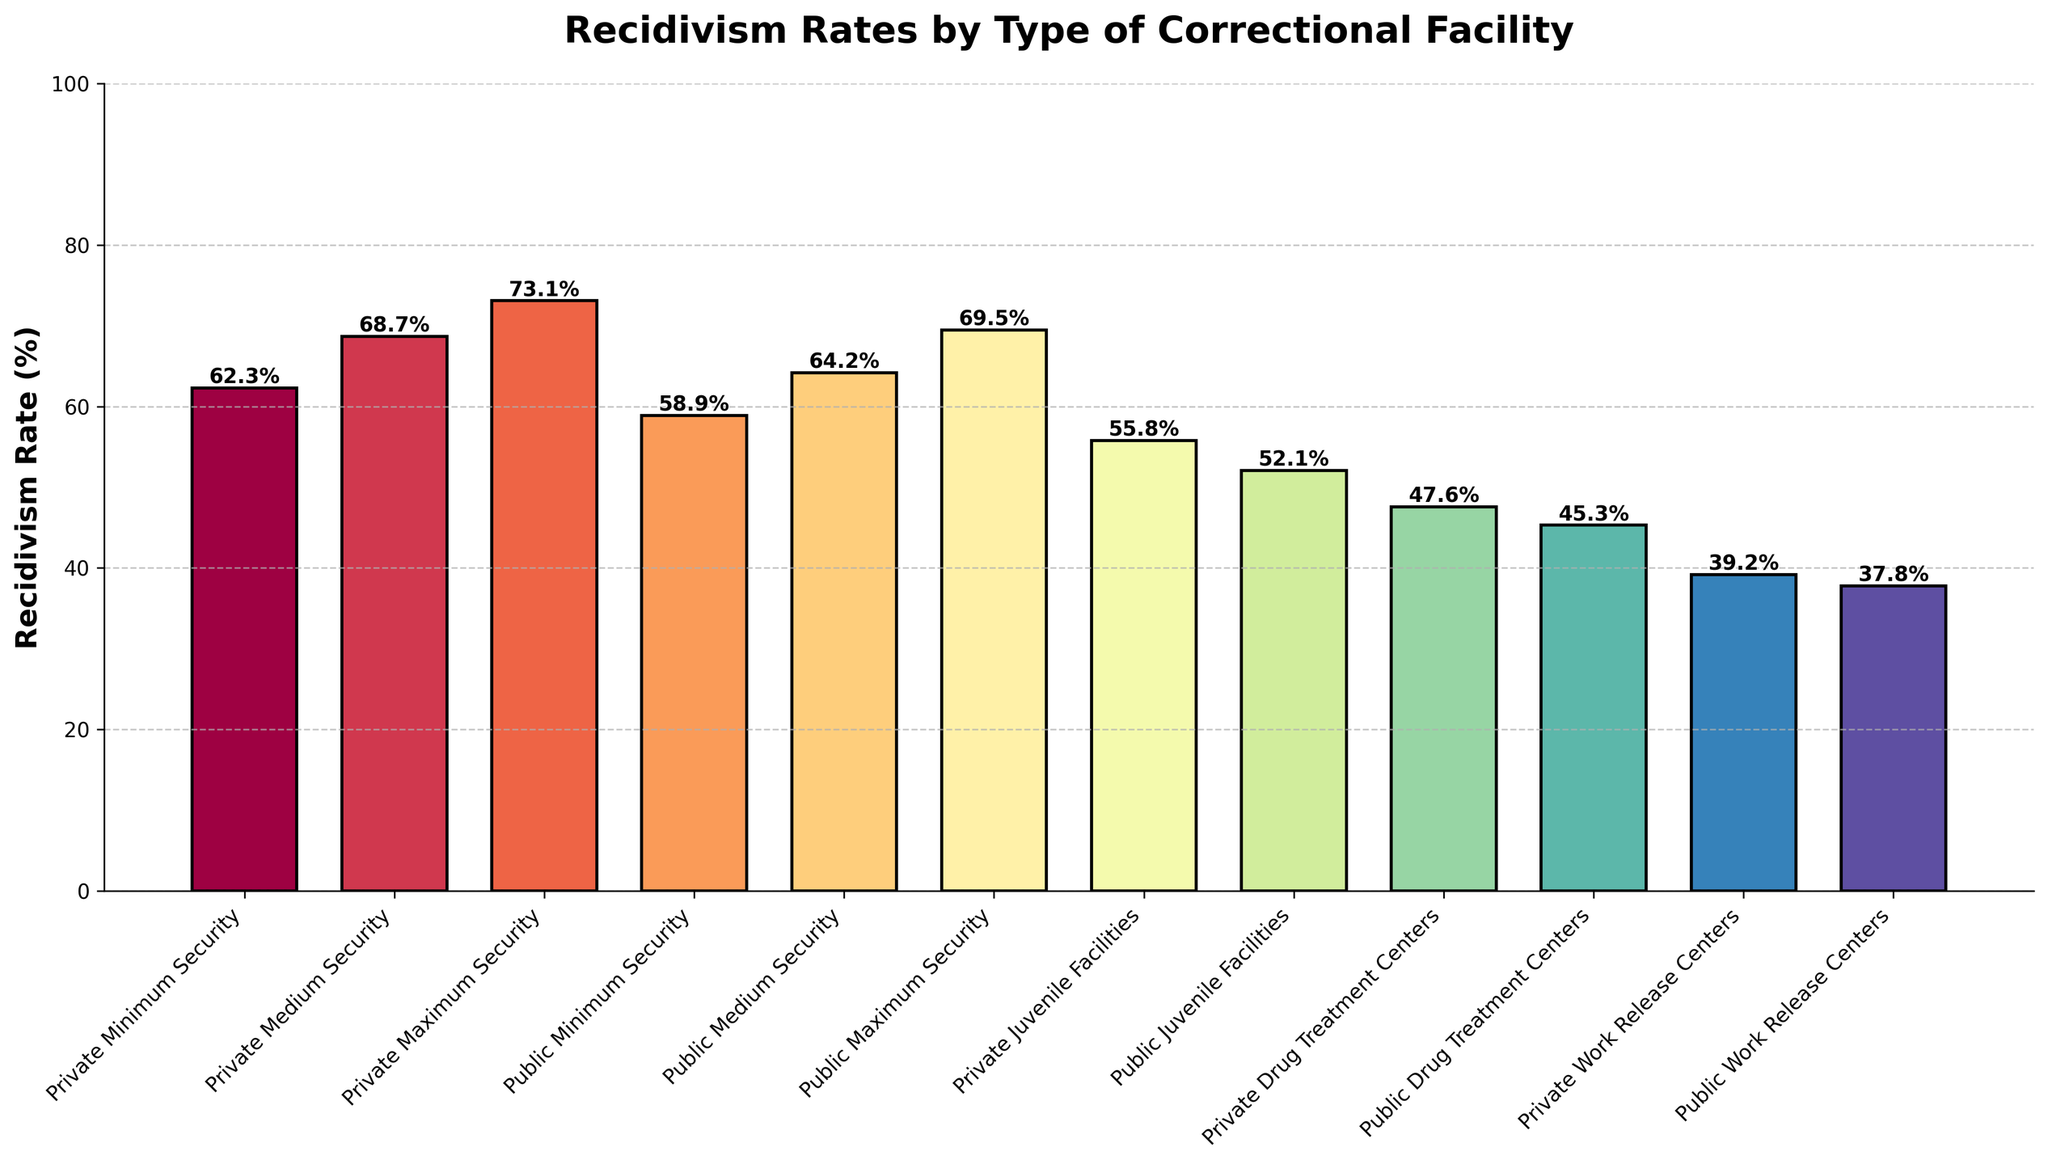What is the recidivism rate for Public Drug Treatment Centers? To find the recidivism rate for Public Drug Treatment Centers, look at the specific bar labeled "Public Drug Treatment Centers" and read the value at the top of the bar which represents the rate as a percentage.
Answer: 45.3% Which facility type has the highest recidivism rate? Compare all the bars in the chart and identify the one with the highest value. The "Private Maximum Security" facility shows the tallest bar, indicating the highest recidivism rate.
Answer: Private Maximum Security What is the difference in recidivism rates between Private Maximum Security and Public Maximum Security facilities? First identify the recidivism rates for both Private Maximum Security (73.1) and Public Maximum Security (69.5) bars. Subtract the rate of Public Maximum Security from Private Maximum Security: 73.1 - 69.5
Answer: 3.6% What is the sum of recidivism rates for all Juvenile facilities? Add the recidivism rates for both Public Juvenile Facilities (52.1) and Private Juvenile Facilities (55.8): 52.1 + 55.8
Answer: 107.9% Which facility type has a lower recidivism rate, Private Work Release Centers or Public Work Release Centers? Compare the heights of the bars for "Private Work Release Centers" (39.2) and "Public Work Release Centers" (37.8). The shorter bar represents the lower rate.
Answer: Public Work Release Centers What is the average recidivism rate across all facility types? Sum all recidivism rates: 62.3 + 68.7 + 73.1 + 58.9 + 64.2 + 69.5 + 55.8 + 52.1 + 47.6 + 45.3 + 39.2 + 37.8 = 674.5. Divide this sum by the number of facility types (12): 674.5 / 12
Answer: 56.2% Which has a higher recidivism rate: Private Juvenile Facilities or Private Drug Treatment Centers? Compare the heights of the corresponding bars for "Private Juvenile Facilities" (55.8) and "Private Drug Treatment Centers" (47.6). The taller bar indicates the higher rate.
Answer: Private Juvenile Facilities What is the visual difference between the highest and lowest recidivism rates? Identify the highest bar ("Private Maximum Security" at 73.1) and the lowest bar ("Public Work Release Centers" at 37.8). The visual difference is the vertical height difference between these two bars. Calculate by subtracting the lowest rate from the highest rate: 73.1 - 37.8
Answer: 35.3% 